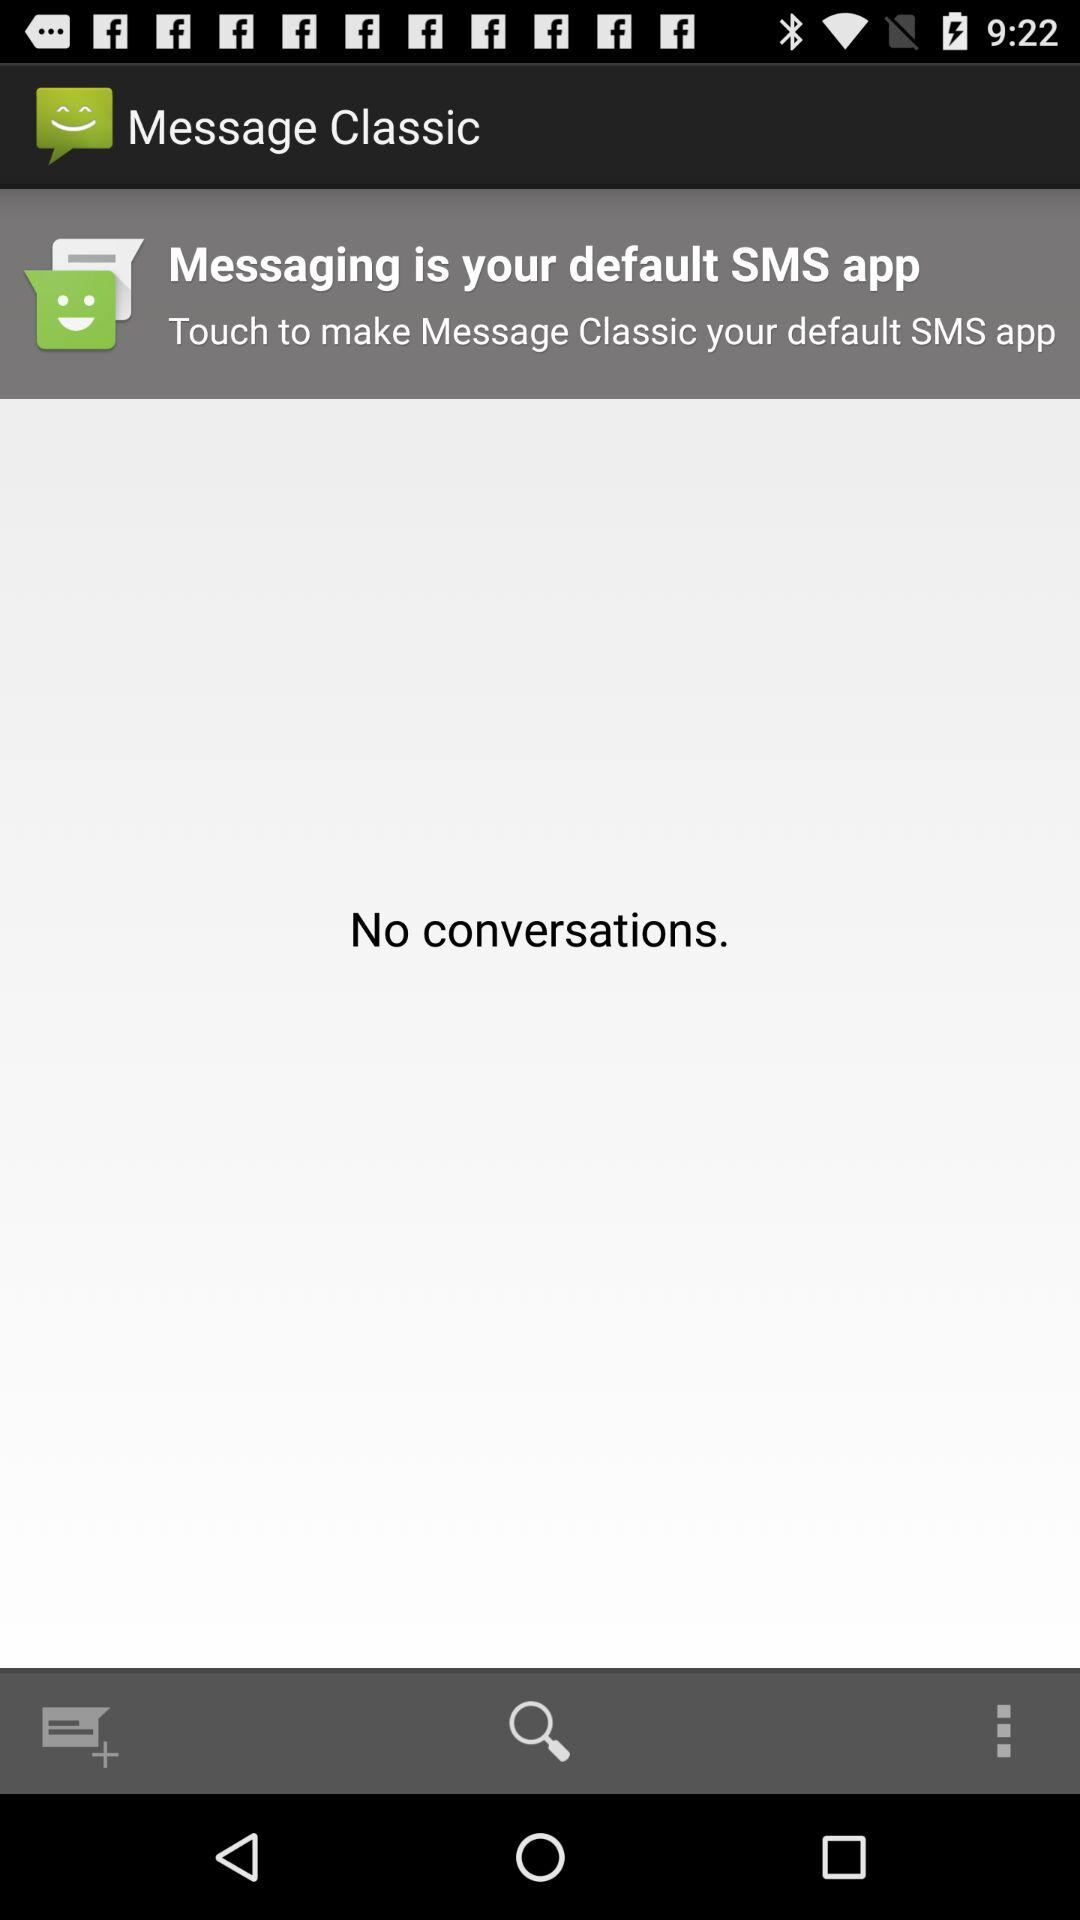Are there any conversations? There are no conversations. 